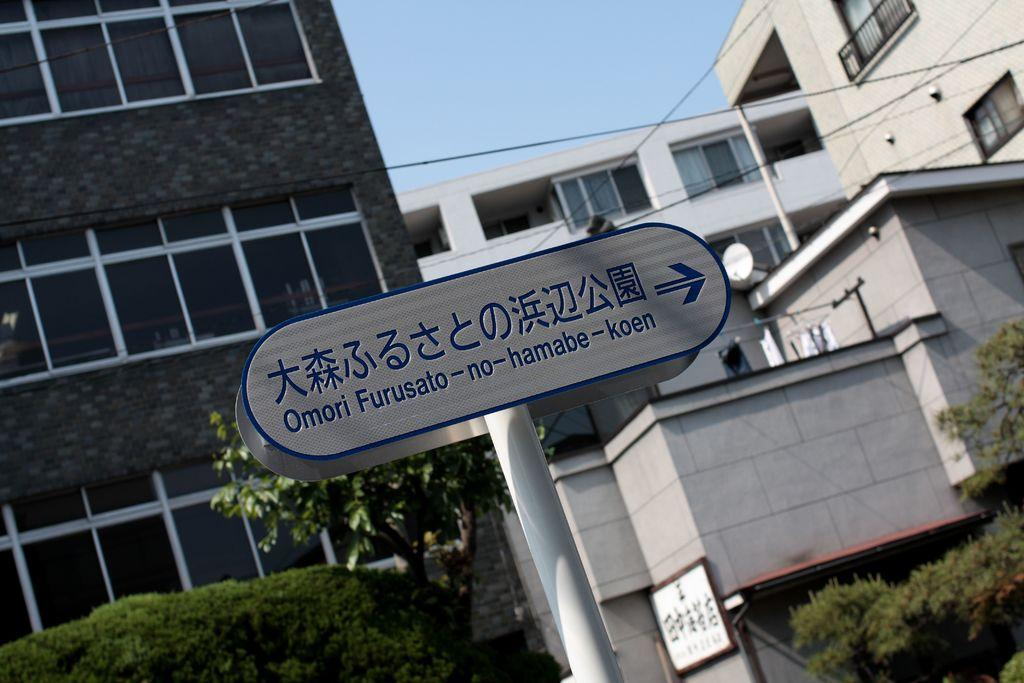What is on the sign board that is visible in the image? There is a sign board with text in the image. What type of vegetation can be seen in the image? There are bushes and trees in the image. What type of structures are present in the image? There are buildings in the image. What is visible at the top of the image? Cables are visible at the top of the image. How many boys are playing on the spring in the image? There are no boys or spring present in the image. What type of shoe is visible on the tree in the image? There is no shoe present in the image; only bushes, trees, buildings, and cables are visible. 